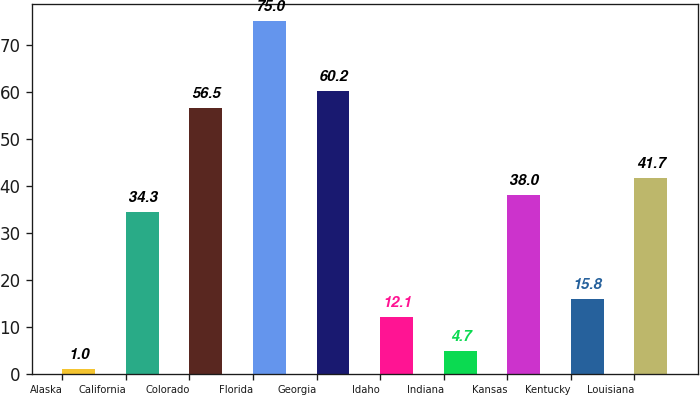Convert chart. <chart><loc_0><loc_0><loc_500><loc_500><bar_chart><fcel>Alaska<fcel>California<fcel>Colorado<fcel>Florida<fcel>Georgia<fcel>Idaho<fcel>Indiana<fcel>Kansas<fcel>Kentucky<fcel>Louisiana<nl><fcel>1<fcel>34.3<fcel>56.5<fcel>75<fcel>60.2<fcel>12.1<fcel>4.7<fcel>38<fcel>15.8<fcel>41.7<nl></chart> 